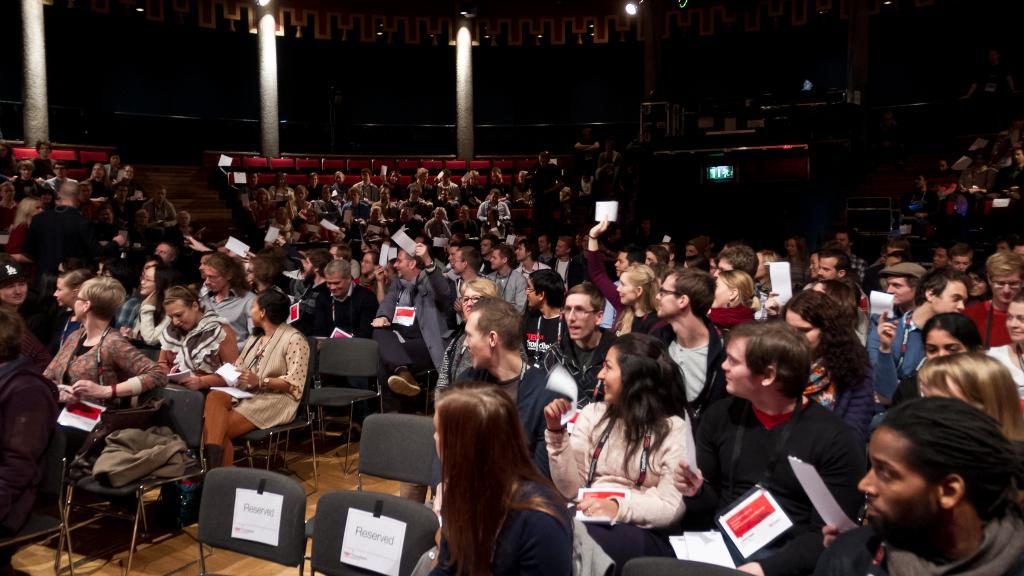How many people are in the image? There is a group of people in the image. What are the people doing in the image? The people are sitting in chairs and holding papers in their hands. What can be seen on the people's clothing? The people are wearing ID cards. What architectural features are visible in the background of the image? There are pillars in the background of the image. What type of lighting is present in the background of the image? There are lights in the background of the image. What type of audio equipment is visible in the background of the image? There are speakers in the background of the image. What type of furniture is visible in the background of the image? There are chairs in the background of the image. What type of cabbage is being served at the station in the image? There is no cabbage or station present in the image. What type of plane can be seen flying in the background of the image? There is no plane visible in the image. 